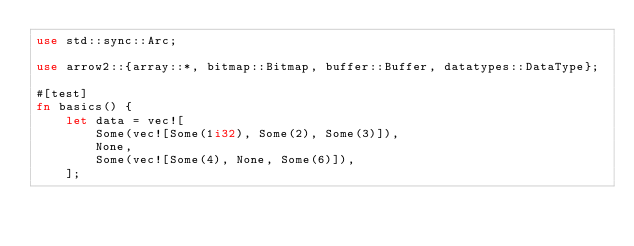<code> <loc_0><loc_0><loc_500><loc_500><_Rust_>use std::sync::Arc;

use arrow2::{array::*, bitmap::Bitmap, buffer::Buffer, datatypes::DataType};

#[test]
fn basics() {
    let data = vec![
        Some(vec![Some(1i32), Some(2), Some(3)]),
        None,
        Some(vec![Some(4), None, Some(6)]),
    ];
</code> 